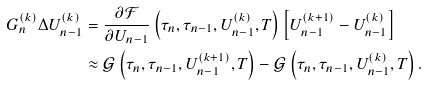<formula> <loc_0><loc_0><loc_500><loc_500>G _ { n } ^ { ( k ) } \Delta U _ { n - 1 } ^ { ( k ) } & = \frac { \partial \mathcal { F } } { \partial U _ { n - 1 } } \left ( \tau _ { n } , \tau _ { n - 1 } , U _ { n - 1 } ^ { ( k ) } , T \right ) \left [ U _ { n - 1 } ^ { ( k + 1 ) } - U _ { n - 1 } ^ { ( k ) } \right ] \\ & \approx \mathcal { G } \left ( \tau _ { n } , \tau _ { n - 1 } , U _ { n - 1 } ^ { ( k + 1 ) } , T \right ) - \mathcal { G } \left ( \tau _ { n } , \tau _ { n - 1 } , U _ { n - 1 } ^ { ( k ) } , T \right ) .</formula> 